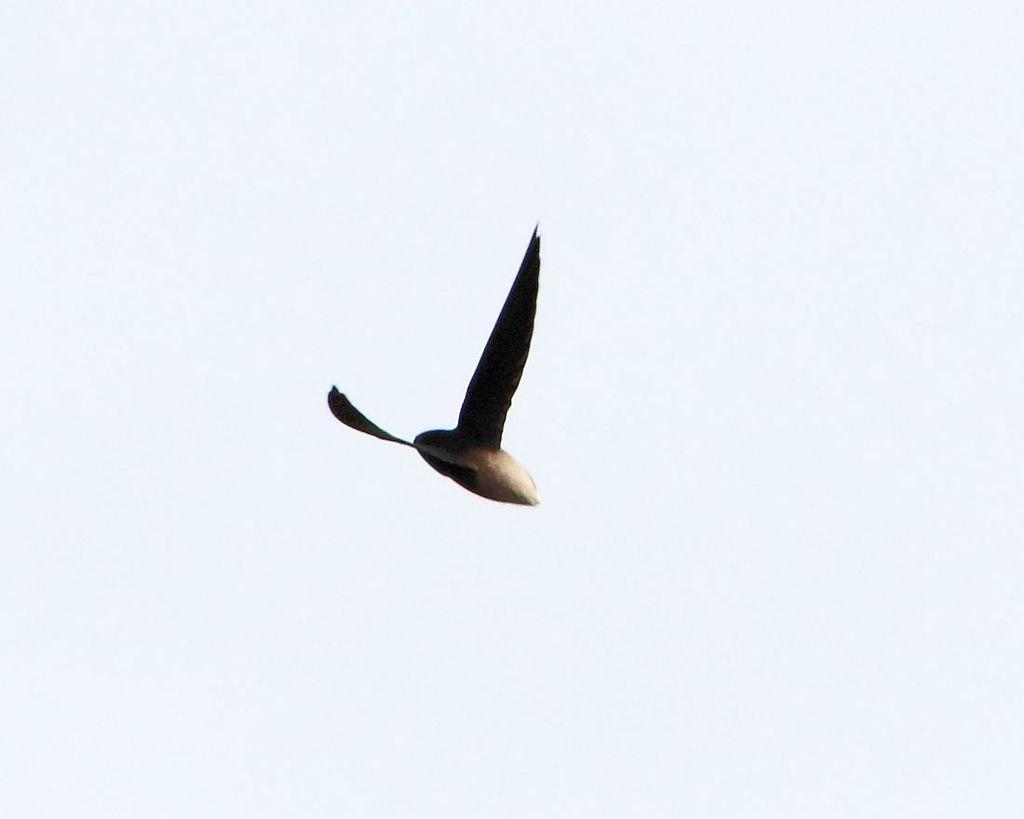What type of animal can be seen in the image? There is a bird in the image. What is the bird doing in the image? The bird is flying in the air. What can be seen in the background of the image? The sky is visible in the background of the image. Can you see a girl playing on the playground in the image? There is no girl or playground present in the image; it features a bird flying in the sky. Is there a kiss between two people visible in the image? There is no kiss or people present in the image; it features a bird flying in the sky. 